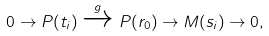Convert formula to latex. <formula><loc_0><loc_0><loc_500><loc_500>0 \to P ( t _ { i } ) \xrightarrow { g } P ( r _ { 0 } ) \to M ( s _ { i } ) \to 0 ,</formula> 